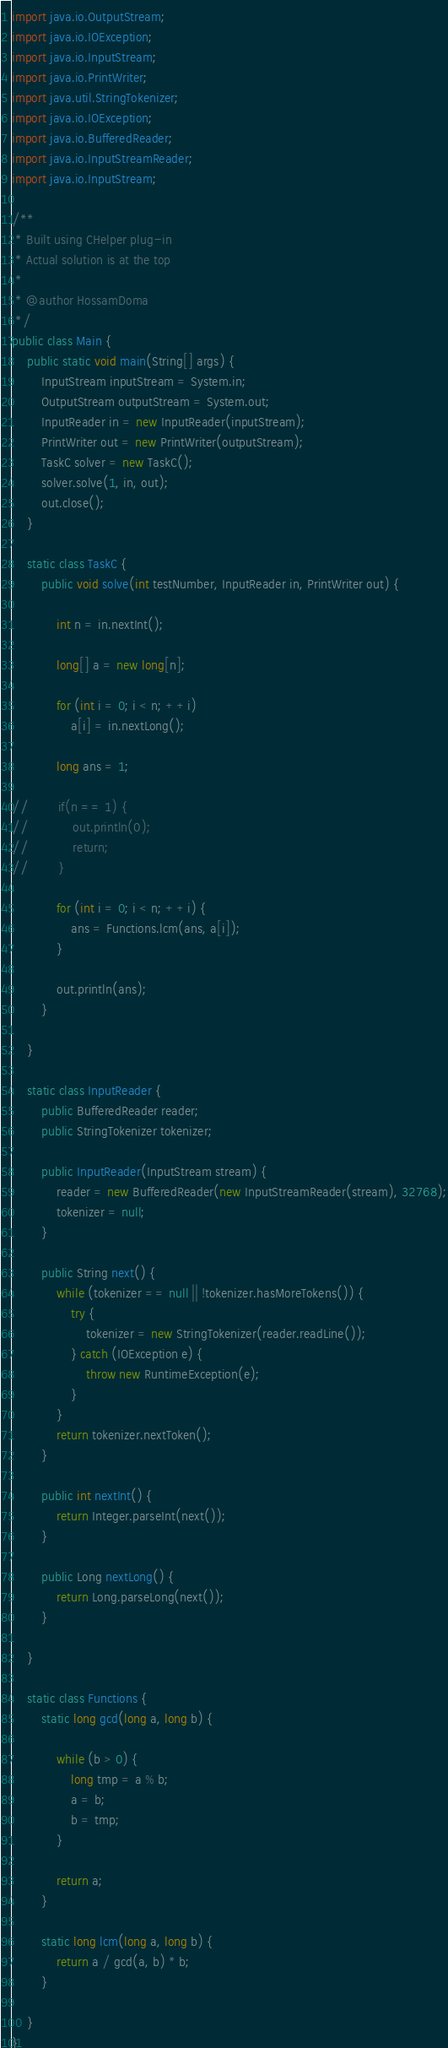<code> <loc_0><loc_0><loc_500><loc_500><_Java_>import java.io.OutputStream;
import java.io.IOException;
import java.io.InputStream;
import java.io.PrintWriter;
import java.util.StringTokenizer;
import java.io.IOException;
import java.io.BufferedReader;
import java.io.InputStreamReader;
import java.io.InputStream;

/**
 * Built using CHelper plug-in
 * Actual solution is at the top
 *
 * @author HossamDoma
 */
public class Main {
    public static void main(String[] args) {
        InputStream inputStream = System.in;
        OutputStream outputStream = System.out;
        InputReader in = new InputReader(inputStream);
        PrintWriter out = new PrintWriter(outputStream);
        TaskC solver = new TaskC();
        solver.solve(1, in, out);
        out.close();
    }

    static class TaskC {
        public void solve(int testNumber, InputReader in, PrintWriter out) {

            int n = in.nextInt();

            long[] a = new long[n];

            for (int i = 0; i < n; ++i)
                a[i] = in.nextLong();

            long ans = 1;

//        if(n == 1) {
//            out.println(0);
//            return;
//        }

            for (int i = 0; i < n; ++i) {
                ans = Functions.lcm(ans, a[i]);
            }

            out.println(ans);
        }

    }

    static class InputReader {
        public BufferedReader reader;
        public StringTokenizer tokenizer;

        public InputReader(InputStream stream) {
            reader = new BufferedReader(new InputStreamReader(stream), 32768);
            tokenizer = null;
        }

        public String next() {
            while (tokenizer == null || !tokenizer.hasMoreTokens()) {
                try {
                    tokenizer = new StringTokenizer(reader.readLine());
                } catch (IOException e) {
                    throw new RuntimeException(e);
                }
            }
            return tokenizer.nextToken();
        }

        public int nextInt() {
            return Integer.parseInt(next());
        }

        public Long nextLong() {
            return Long.parseLong(next());
        }

    }

    static class Functions {
        static long gcd(long a, long b) {

            while (b > 0) {
                long tmp = a % b;
                a = b;
                b = tmp;
            }

            return a;
        }

        static long lcm(long a, long b) {
            return a / gcd(a, b) * b;
        }

    }
}

</code> 